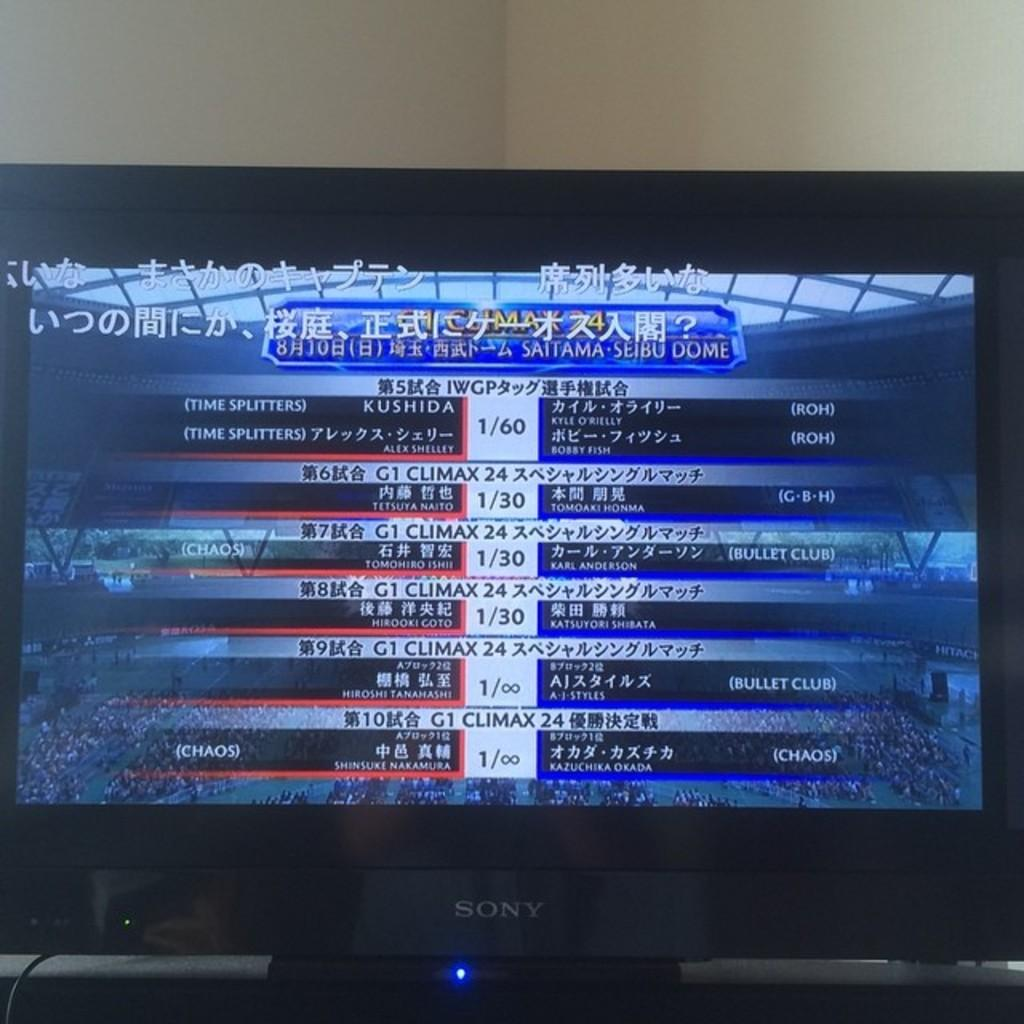<image>
Create a compact narrative representing the image presented. Scores for a competition at Saitama Seibu Dome displayed on a Sony monitor 